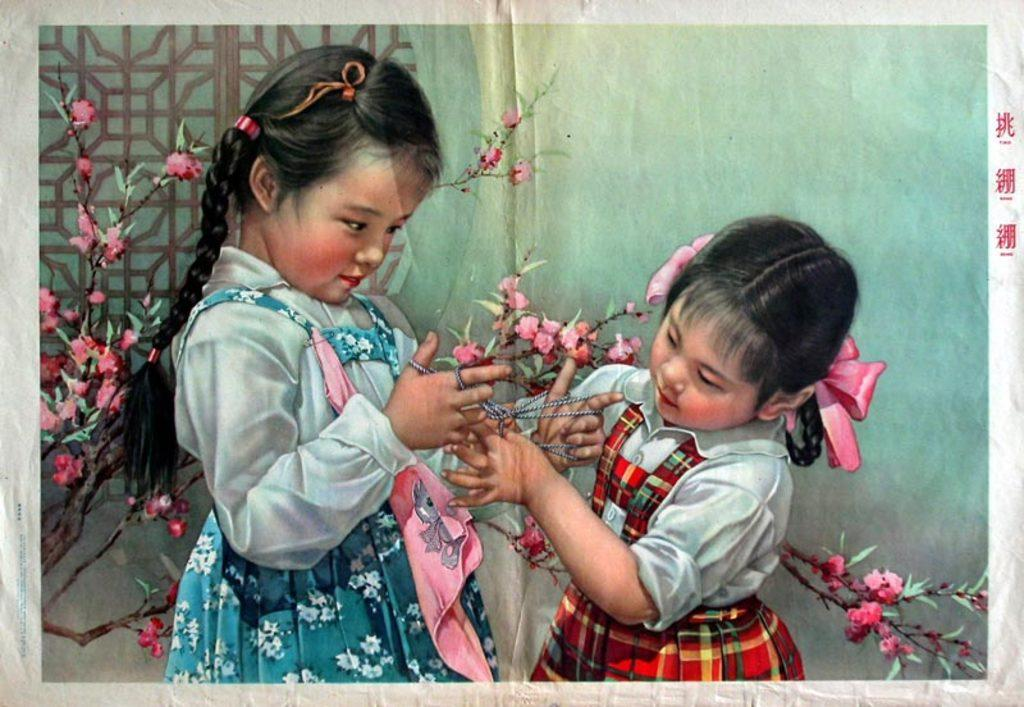What is featured in the image? There is a poster in the image. What is depicted on the poster? The poster depicts two girls. What are the girls doing in the poster? The girls are doing something with thread. What can be seen in the background of the poster? There are flowers with leaves and stems, a wall, and a grill in the background of the poster. How many brothers are present in the image? There are no brothers present in the image; it features a poster with two girls. What type of books can be seen on the grill in the image? There are no books visible in the image, and the grill is not associated with any books. 